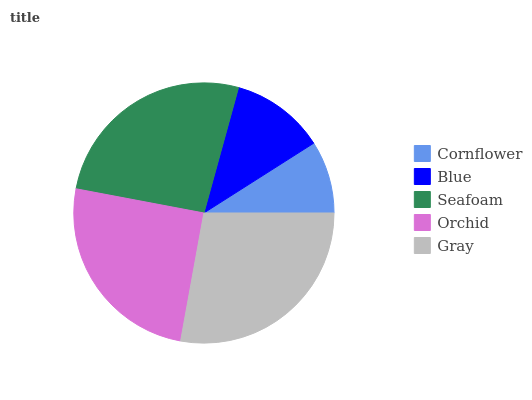Is Cornflower the minimum?
Answer yes or no. Yes. Is Gray the maximum?
Answer yes or no. Yes. Is Blue the minimum?
Answer yes or no. No. Is Blue the maximum?
Answer yes or no. No. Is Blue greater than Cornflower?
Answer yes or no. Yes. Is Cornflower less than Blue?
Answer yes or no. Yes. Is Cornflower greater than Blue?
Answer yes or no. No. Is Blue less than Cornflower?
Answer yes or no. No. Is Orchid the high median?
Answer yes or no. Yes. Is Orchid the low median?
Answer yes or no. Yes. Is Cornflower the high median?
Answer yes or no. No. Is Seafoam the low median?
Answer yes or no. No. 